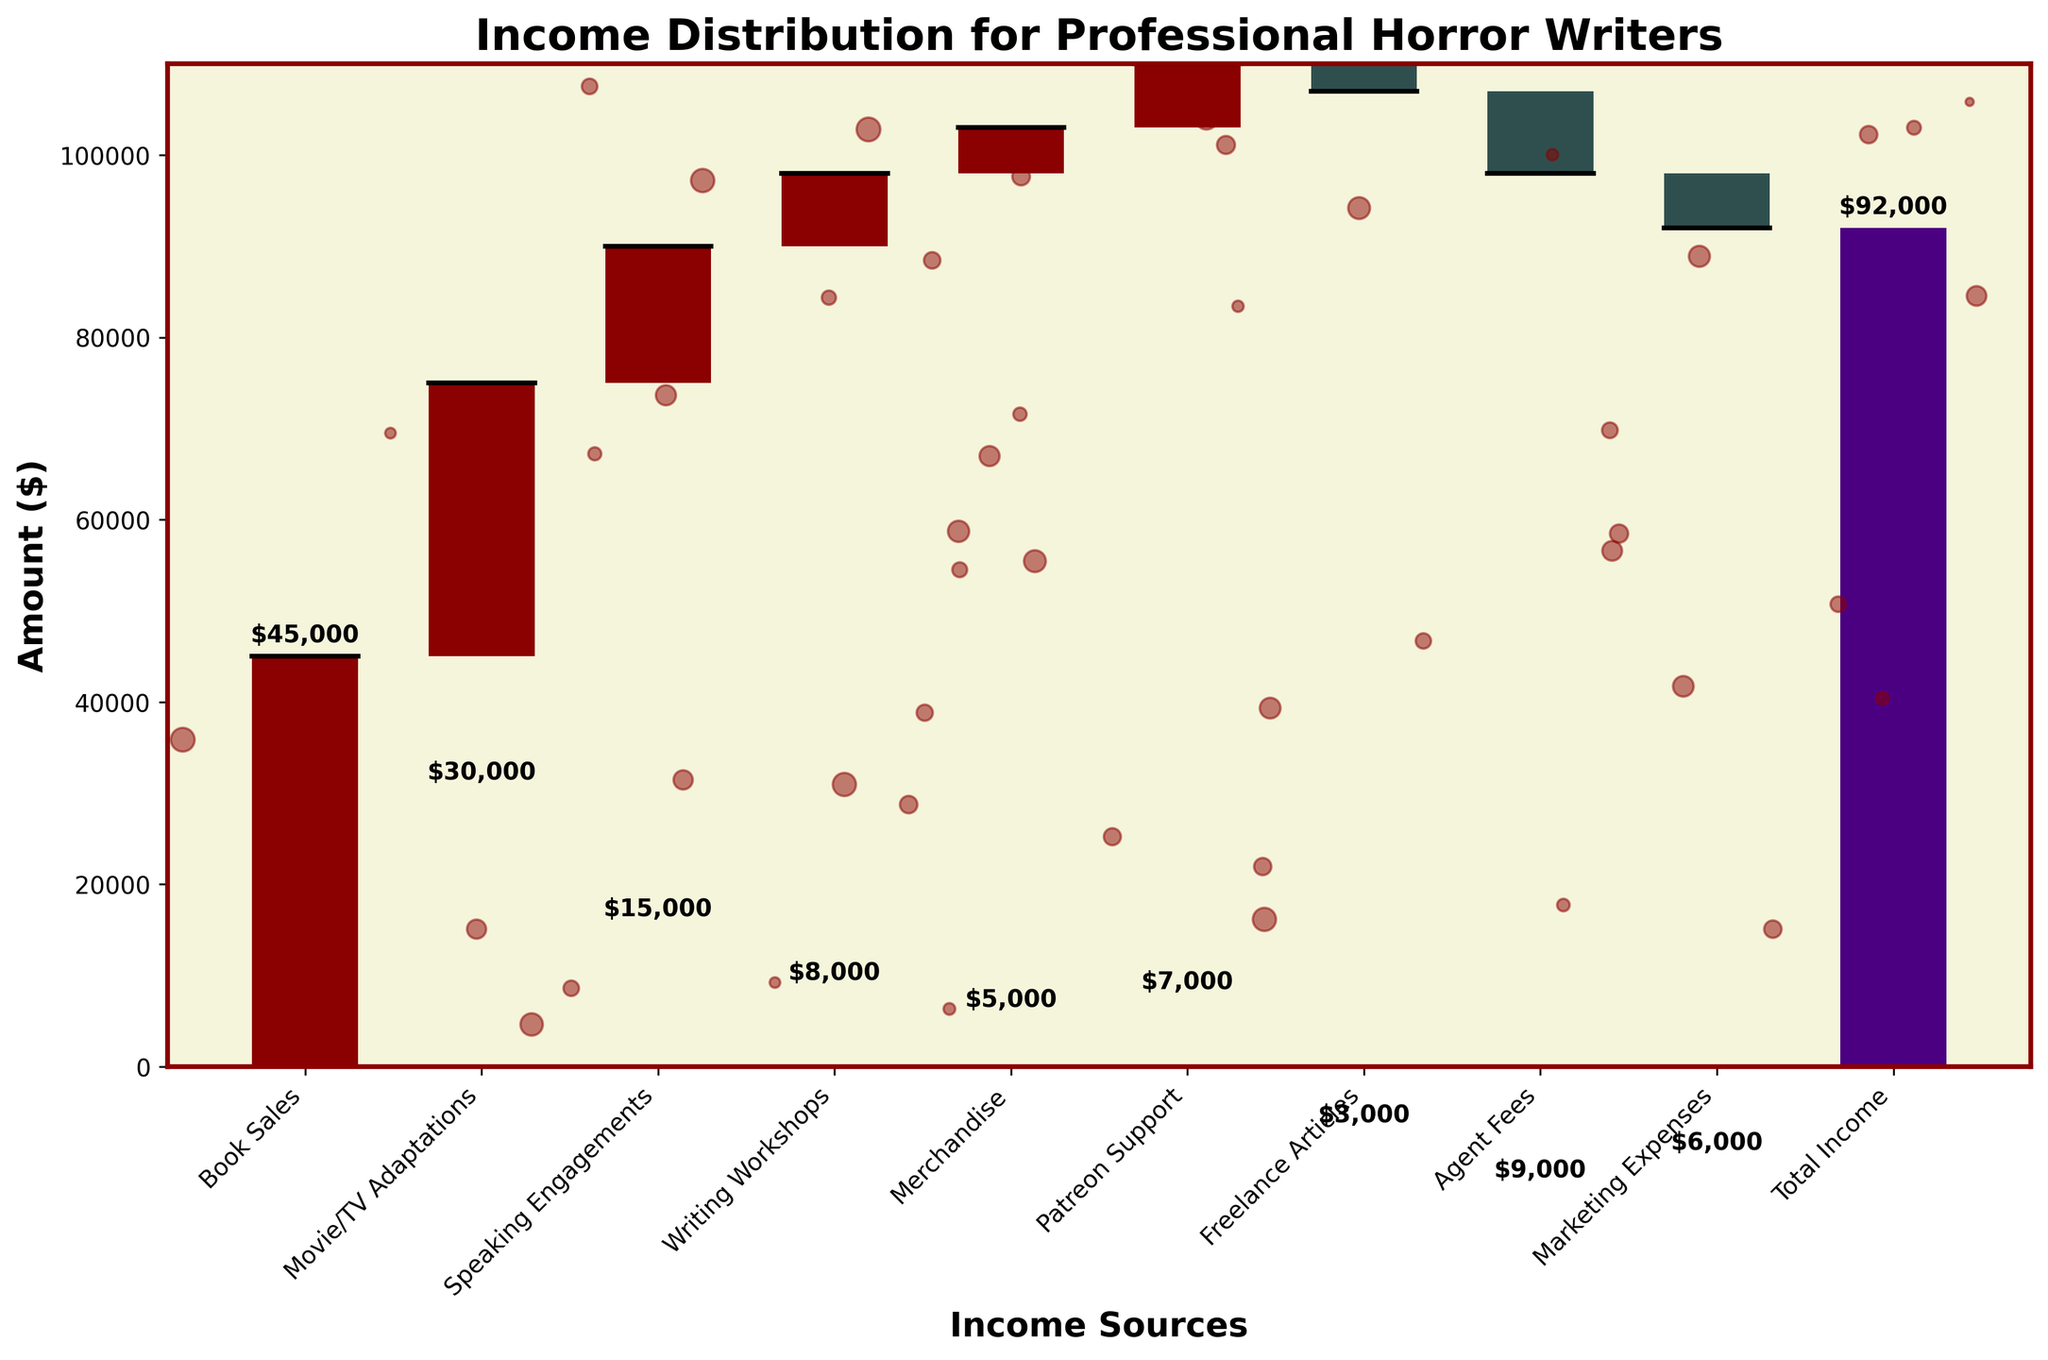What is the title of the chart? The title is usually located at the top of the chart. It is often highlighted and given in a larger font size compared to other texts.
Answer: Income Distribution for Professional Horror Writers What is the total income for professional horror writers? The total income is represented by the last bar in the chart. This bar is often distinctly colored (e.g., purple) and labeled at the rightmost position.
Answer: $92,000 Which income source contributes the most to the total income? To answer this, you need to look for the tallest bar that signifies a positive contribution. From the chart, the "Book Sales" bar is the tallest among the positive contributors.
Answer: Book Sales What are the negative contributions in the chart, and what do they represent? Negative contributions are often indicated by bars colored differently (e.g., dark) and appear below the baseline. From the chart, they are "Freelance Articles," "Agent Fees," and "Marketing Expenses." These bars represent expenses or losses.
Answer: Freelance Articles, Agent Fees, Marketing Expenses How does the cumulative income change after "Movie/TV Adaptations"? First, identify the cumulative sum before and after the "Movie/TV Adaptations" bar. Calculate the combined sum from previous bars leading up to it, then add its value.
Answer: Increases by $30,000 Compare the "Writing Workshops" income to "Patreon Support." Which one is higher and by how much? First, identify the heights of both bars. "Writing Workshops" has $8,000 and "Patreon Support" has $7,000. Subtract these values to get the difference.
Answer: Writing Workshops by $1,000 What is the total revenue generated from all positive income sources? Sum up all the values of positive contributors: $45,000 (Book Sales) + $30,000 (Movie/TV Adaptations) + $15,000 (Speaking Engagements) + $8,000 (Writing Workshops) + $5,000 (Merchandise) + $7,000 (Patreon Support) = $110,000.
Answer: $110,000 If the negative expenses were halved, what would the new total income be? First, halve the negative values: Freelance Articles = -$1,500, Agent Fees = -$4,500, Marketing Expenses = -$3,000. Sum all values including positives and these new negatives: $110,000 - $1,500 - $4,500 - $3,000 = $101,000.
Answer: $101,000 What is the ratio of income from "Speaking Engagements" compared to income loss due to "Agent Fees"? Divide the value of "Speaking Engagements" ($15,000) by the absolute value of "Agent Fees" ($9,000).
Answer: 5:3 What is the net effect of "Writing Workshops" and "Agent Fees" combined? Sum the values of "Writing Workshops" and "Agent Fees": $8,000 - $9,000 = -$1,000.
Answer: -$1,000 